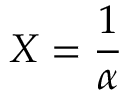<formula> <loc_0><loc_0><loc_500><loc_500>X = { \frac { 1 } { \alpha } }</formula> 